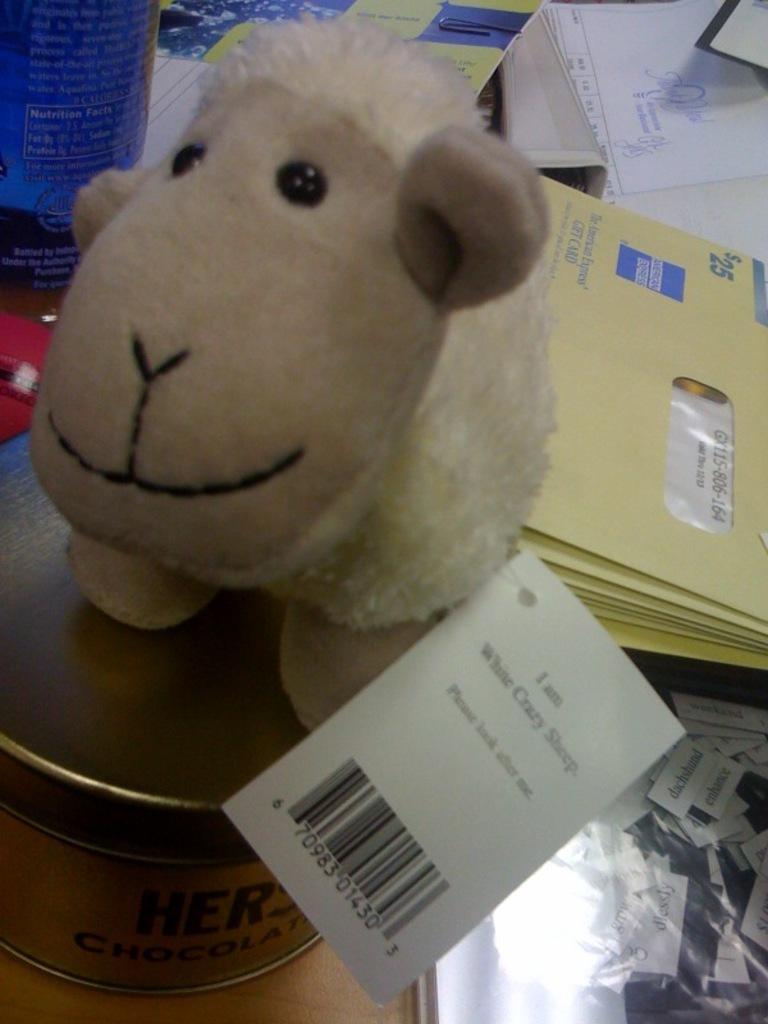Describe this image in one or two sentences. This image consists of a doll. At the bottom, we can see a box. In the background, there are envelopes and papers. 